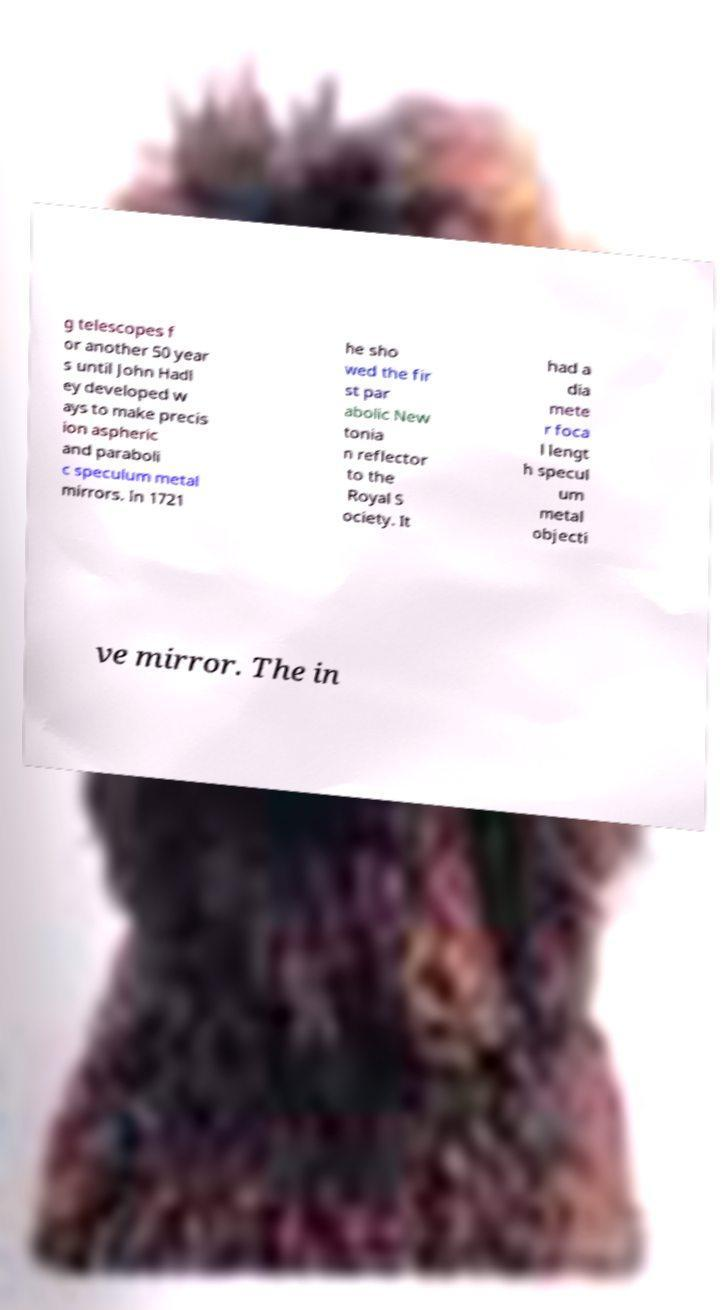Could you assist in decoding the text presented in this image and type it out clearly? g telescopes f or another 50 year s until John Hadl ey developed w ays to make precis ion aspheric and paraboli c speculum metal mirrors. In 1721 he sho wed the fir st par abolic New tonia n reflector to the Royal S ociety. It had a dia mete r foca l lengt h specul um metal objecti ve mirror. The in 